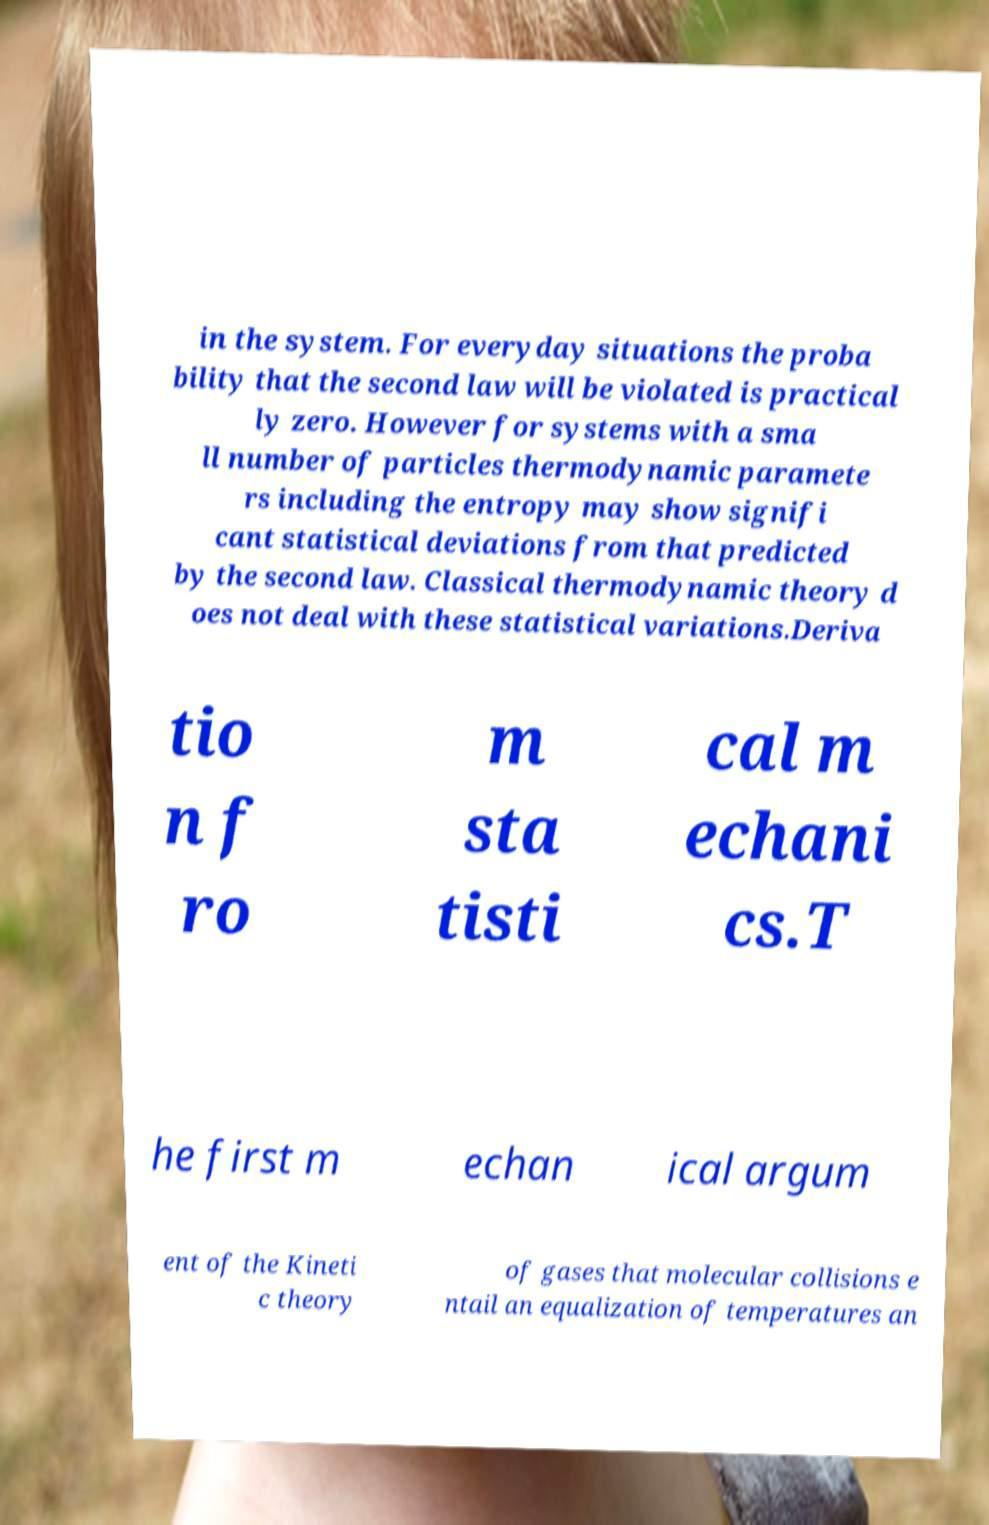Please read and relay the text visible in this image. What does it say? in the system. For everyday situations the proba bility that the second law will be violated is practical ly zero. However for systems with a sma ll number of particles thermodynamic paramete rs including the entropy may show signifi cant statistical deviations from that predicted by the second law. Classical thermodynamic theory d oes not deal with these statistical variations.Deriva tio n f ro m sta tisti cal m echani cs.T he first m echan ical argum ent of the Kineti c theory of gases that molecular collisions e ntail an equalization of temperatures an 